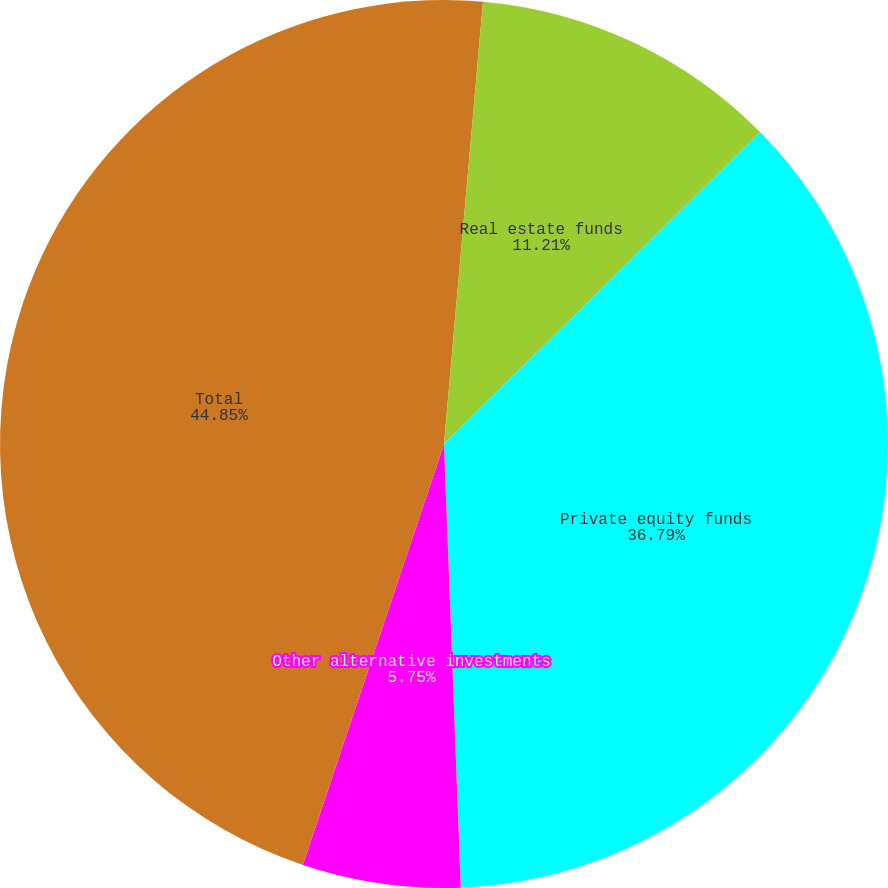Convert chart. <chart><loc_0><loc_0><loc_500><loc_500><pie_chart><fcel>Hedge funds<fcel>Real estate funds<fcel>Private equity funds<fcel>Other alternative investments<fcel>Total<nl><fcel>1.4%<fcel>11.21%<fcel>36.79%<fcel>5.75%<fcel>44.85%<nl></chart> 